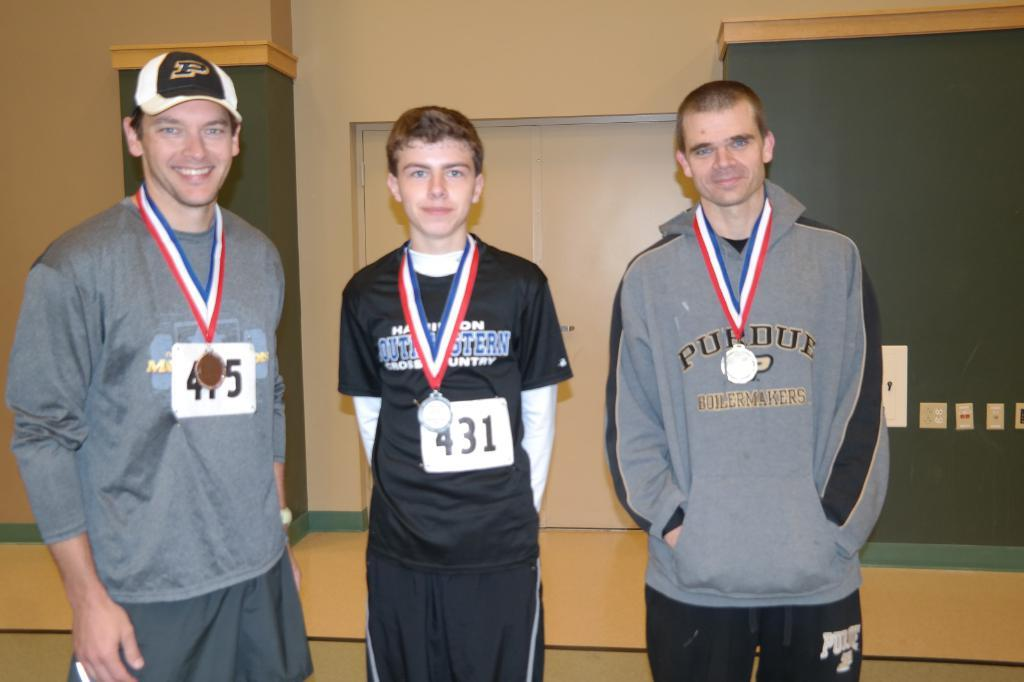Provide a one-sentence caption for the provided image. Three people receive medals at a convention, including number 431. 